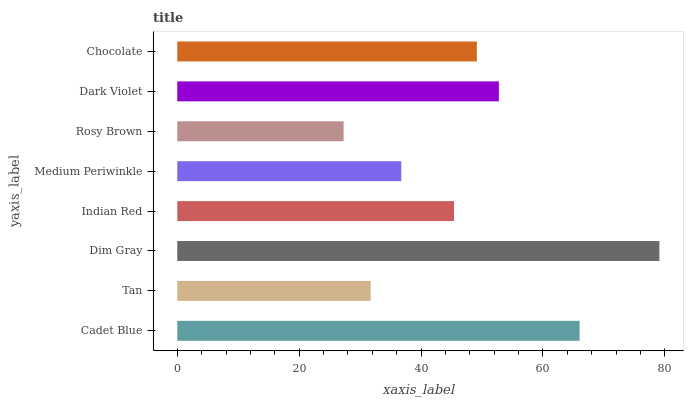Is Rosy Brown the minimum?
Answer yes or no. Yes. Is Dim Gray the maximum?
Answer yes or no. Yes. Is Tan the minimum?
Answer yes or no. No. Is Tan the maximum?
Answer yes or no. No. Is Cadet Blue greater than Tan?
Answer yes or no. Yes. Is Tan less than Cadet Blue?
Answer yes or no. Yes. Is Tan greater than Cadet Blue?
Answer yes or no. No. Is Cadet Blue less than Tan?
Answer yes or no. No. Is Chocolate the high median?
Answer yes or no. Yes. Is Indian Red the low median?
Answer yes or no. Yes. Is Dim Gray the high median?
Answer yes or no. No. Is Rosy Brown the low median?
Answer yes or no. No. 